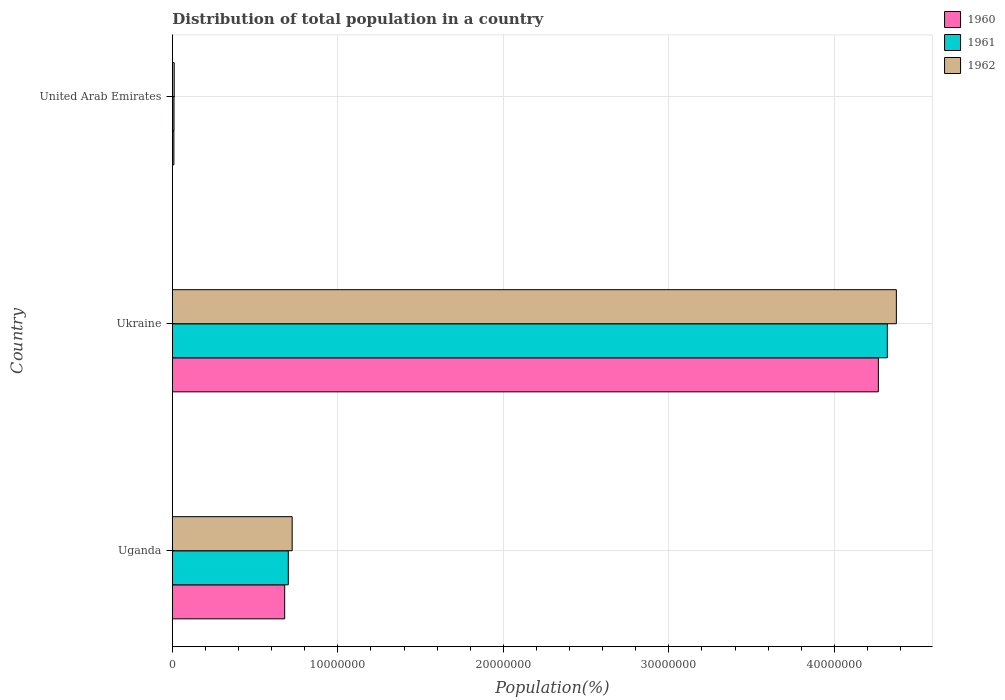How many bars are there on the 3rd tick from the bottom?
Provide a succinct answer. 3. What is the label of the 2nd group of bars from the top?
Your response must be concise. Ukraine. In how many cases, is the number of bars for a given country not equal to the number of legend labels?
Provide a short and direct response. 0. What is the population of in 1962 in United Arab Emirates?
Make the answer very short. 1.12e+05. Across all countries, what is the maximum population of in 1960?
Make the answer very short. 4.27e+07. Across all countries, what is the minimum population of in 1960?
Your answer should be compact. 9.26e+04. In which country was the population of in 1961 maximum?
Ensure brevity in your answer.  Ukraine. In which country was the population of in 1961 minimum?
Your answer should be very brief. United Arab Emirates. What is the total population of in 1961 in the graph?
Your answer should be very brief. 5.03e+07. What is the difference between the population of in 1962 in Uganda and that in Ukraine?
Offer a terse response. -3.65e+07. What is the difference between the population of in 1961 in Uganda and the population of in 1960 in Ukraine?
Your response must be concise. -3.57e+07. What is the average population of in 1962 per country?
Your answer should be compact. 1.70e+07. What is the difference between the population of in 1961 and population of in 1962 in United Arab Emirates?
Keep it short and to the point. -1.13e+04. In how many countries, is the population of in 1960 greater than 4000000 %?
Offer a terse response. 2. What is the ratio of the population of in 1960 in Ukraine to that in United Arab Emirates?
Ensure brevity in your answer.  460.65. Is the difference between the population of in 1961 in Ukraine and United Arab Emirates greater than the difference between the population of in 1962 in Ukraine and United Arab Emirates?
Keep it short and to the point. No. What is the difference between the highest and the second highest population of in 1960?
Keep it short and to the point. 3.59e+07. What is the difference between the highest and the lowest population of in 1960?
Offer a terse response. 4.26e+07. What does the 3rd bar from the top in Uganda represents?
Give a very brief answer. 1960. What does the 2nd bar from the bottom in Ukraine represents?
Your answer should be very brief. 1961. How many bars are there?
Offer a very short reply. 9. Are all the bars in the graph horizontal?
Provide a succinct answer. Yes. How many countries are there in the graph?
Keep it short and to the point. 3. Where does the legend appear in the graph?
Your answer should be very brief. Top right. How many legend labels are there?
Offer a very short reply. 3. How are the legend labels stacked?
Your answer should be compact. Vertical. What is the title of the graph?
Your response must be concise. Distribution of total population in a country. What is the label or title of the X-axis?
Ensure brevity in your answer.  Population(%). What is the Population(%) of 1960 in Uganda?
Your response must be concise. 6.79e+06. What is the Population(%) in 1961 in Uganda?
Your answer should be compact. 7.01e+06. What is the Population(%) of 1962 in Uganda?
Offer a very short reply. 7.24e+06. What is the Population(%) in 1960 in Ukraine?
Give a very brief answer. 4.27e+07. What is the Population(%) in 1961 in Ukraine?
Offer a terse response. 4.32e+07. What is the Population(%) in 1962 in Ukraine?
Offer a very short reply. 4.37e+07. What is the Population(%) of 1960 in United Arab Emirates?
Offer a very short reply. 9.26e+04. What is the Population(%) in 1961 in United Arab Emirates?
Give a very brief answer. 1.01e+05. What is the Population(%) of 1962 in United Arab Emirates?
Keep it short and to the point. 1.12e+05. Across all countries, what is the maximum Population(%) of 1960?
Make the answer very short. 4.27e+07. Across all countries, what is the maximum Population(%) in 1961?
Offer a very short reply. 4.32e+07. Across all countries, what is the maximum Population(%) in 1962?
Offer a very short reply. 4.37e+07. Across all countries, what is the minimum Population(%) in 1960?
Your response must be concise. 9.26e+04. Across all countries, what is the minimum Population(%) in 1961?
Provide a succinct answer. 1.01e+05. Across all countries, what is the minimum Population(%) of 1962?
Provide a short and direct response. 1.12e+05. What is the total Population(%) of 1960 in the graph?
Offer a very short reply. 4.95e+07. What is the total Population(%) in 1961 in the graph?
Your answer should be very brief. 5.03e+07. What is the total Population(%) of 1962 in the graph?
Your answer should be compact. 5.11e+07. What is the difference between the Population(%) in 1960 in Uganda and that in Ukraine?
Provide a succinct answer. -3.59e+07. What is the difference between the Population(%) of 1961 in Uganda and that in Ukraine?
Your response must be concise. -3.62e+07. What is the difference between the Population(%) in 1962 in Uganda and that in Ukraine?
Your answer should be compact. -3.65e+07. What is the difference between the Population(%) in 1960 in Uganda and that in United Arab Emirates?
Your response must be concise. 6.70e+06. What is the difference between the Population(%) of 1961 in Uganda and that in United Arab Emirates?
Make the answer very short. 6.91e+06. What is the difference between the Population(%) of 1962 in Uganda and that in United Arab Emirates?
Your response must be concise. 7.13e+06. What is the difference between the Population(%) of 1960 in Ukraine and that in United Arab Emirates?
Your response must be concise. 4.26e+07. What is the difference between the Population(%) in 1961 in Ukraine and that in United Arab Emirates?
Give a very brief answer. 4.31e+07. What is the difference between the Population(%) of 1962 in Ukraine and that in United Arab Emirates?
Your response must be concise. 4.36e+07. What is the difference between the Population(%) of 1960 in Uganda and the Population(%) of 1961 in Ukraine?
Your answer should be compact. -3.64e+07. What is the difference between the Population(%) in 1960 in Uganda and the Population(%) in 1962 in Ukraine?
Give a very brief answer. -3.70e+07. What is the difference between the Population(%) in 1961 in Uganda and the Population(%) in 1962 in Ukraine?
Offer a very short reply. -3.67e+07. What is the difference between the Population(%) of 1960 in Uganda and the Population(%) of 1961 in United Arab Emirates?
Your response must be concise. 6.69e+06. What is the difference between the Population(%) in 1960 in Uganda and the Population(%) in 1962 in United Arab Emirates?
Provide a short and direct response. 6.68e+06. What is the difference between the Population(%) in 1961 in Uganda and the Population(%) in 1962 in United Arab Emirates?
Your answer should be very brief. 6.89e+06. What is the difference between the Population(%) in 1960 in Ukraine and the Population(%) in 1961 in United Arab Emirates?
Your response must be concise. 4.26e+07. What is the difference between the Population(%) in 1960 in Ukraine and the Population(%) in 1962 in United Arab Emirates?
Keep it short and to the point. 4.25e+07. What is the difference between the Population(%) of 1961 in Ukraine and the Population(%) of 1962 in United Arab Emirates?
Provide a short and direct response. 4.31e+07. What is the average Population(%) of 1960 per country?
Provide a short and direct response. 1.65e+07. What is the average Population(%) of 1961 per country?
Give a very brief answer. 1.68e+07. What is the average Population(%) of 1962 per country?
Provide a succinct answer. 1.70e+07. What is the difference between the Population(%) in 1960 and Population(%) in 1961 in Uganda?
Your answer should be very brief. -2.18e+05. What is the difference between the Population(%) of 1960 and Population(%) of 1962 in Uganda?
Offer a very short reply. -4.52e+05. What is the difference between the Population(%) of 1961 and Population(%) of 1962 in Uganda?
Your answer should be very brief. -2.34e+05. What is the difference between the Population(%) of 1960 and Population(%) of 1961 in Ukraine?
Your answer should be compact. -5.41e+05. What is the difference between the Population(%) of 1960 and Population(%) of 1962 in Ukraine?
Give a very brief answer. -1.09e+06. What is the difference between the Population(%) of 1961 and Population(%) of 1962 in Ukraine?
Offer a terse response. -5.46e+05. What is the difference between the Population(%) in 1960 and Population(%) in 1961 in United Arab Emirates?
Provide a succinct answer. -8373. What is the difference between the Population(%) of 1960 and Population(%) of 1962 in United Arab Emirates?
Your response must be concise. -1.96e+04. What is the difference between the Population(%) in 1961 and Population(%) in 1962 in United Arab Emirates?
Your response must be concise. -1.13e+04. What is the ratio of the Population(%) in 1960 in Uganda to that in Ukraine?
Make the answer very short. 0.16. What is the ratio of the Population(%) of 1961 in Uganda to that in Ukraine?
Your answer should be very brief. 0.16. What is the ratio of the Population(%) in 1962 in Uganda to that in Ukraine?
Keep it short and to the point. 0.17. What is the ratio of the Population(%) in 1960 in Uganda to that in United Arab Emirates?
Your answer should be very brief. 73.3. What is the ratio of the Population(%) in 1961 in Uganda to that in United Arab Emirates?
Your response must be concise. 69.38. What is the ratio of the Population(%) of 1962 in Uganda to that in United Arab Emirates?
Offer a very short reply. 64.51. What is the ratio of the Population(%) in 1960 in Ukraine to that in United Arab Emirates?
Your answer should be very brief. 460.65. What is the ratio of the Population(%) in 1961 in Ukraine to that in United Arab Emirates?
Your answer should be very brief. 427.82. What is the ratio of the Population(%) in 1962 in Ukraine to that in United Arab Emirates?
Offer a terse response. 389.79. What is the difference between the highest and the second highest Population(%) of 1960?
Provide a succinct answer. 3.59e+07. What is the difference between the highest and the second highest Population(%) in 1961?
Ensure brevity in your answer.  3.62e+07. What is the difference between the highest and the second highest Population(%) in 1962?
Ensure brevity in your answer.  3.65e+07. What is the difference between the highest and the lowest Population(%) in 1960?
Ensure brevity in your answer.  4.26e+07. What is the difference between the highest and the lowest Population(%) in 1961?
Your answer should be very brief. 4.31e+07. What is the difference between the highest and the lowest Population(%) in 1962?
Provide a short and direct response. 4.36e+07. 